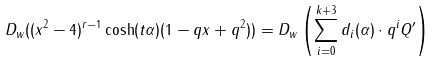Convert formula to latex. <formula><loc_0><loc_0><loc_500><loc_500>D _ { w } ( ( x ^ { 2 } - 4 ) ^ { r - 1 } \cosh ( t \alpha ) ( 1 - q x + q ^ { 2 } ) ) = D _ { w } \left ( \sum _ { i = 0 } ^ { k + 3 } d _ { i } ( \alpha ) \cdot q ^ { i } Q ^ { \prime } \right )</formula> 